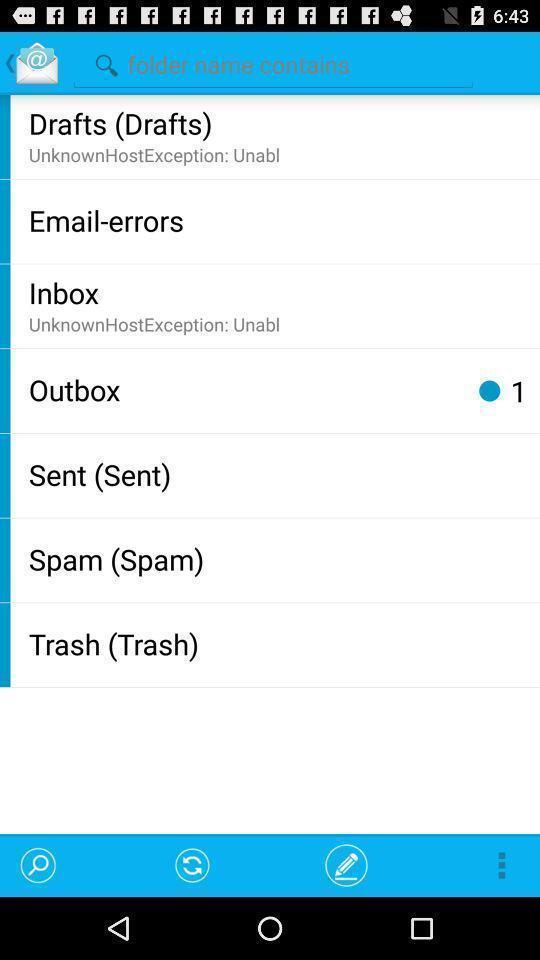Please provide a description for this image. Search page for searching a folder. 